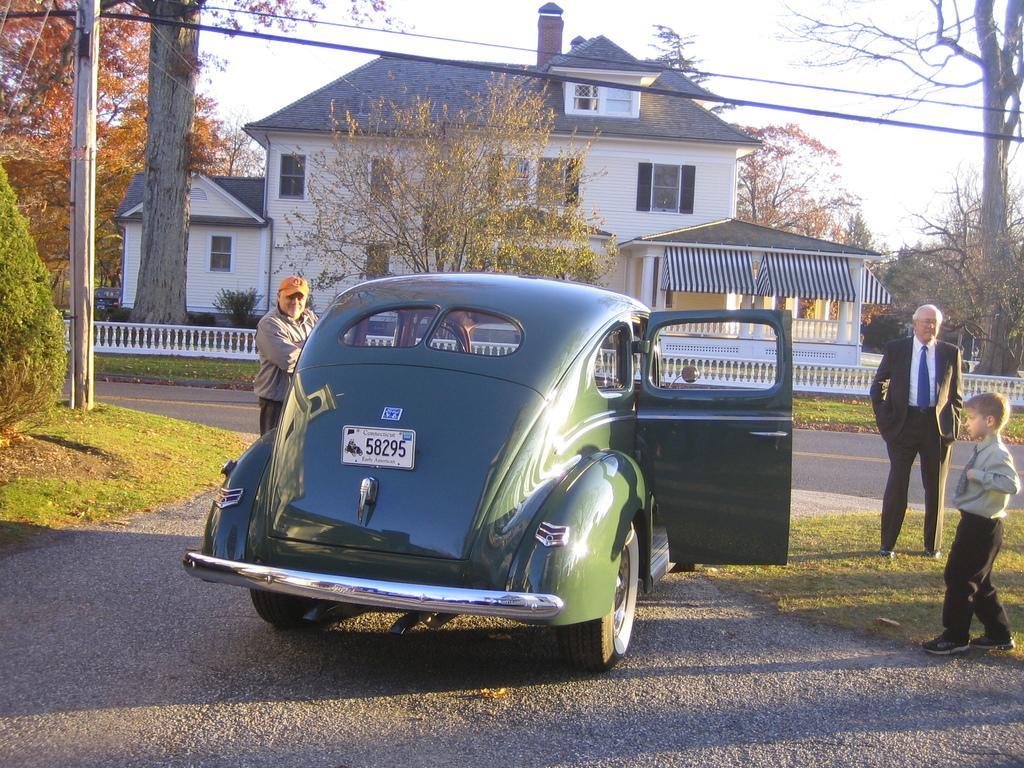Describe this image in one or two sentences. In this image there is a car on the road in the bottom of this image. There are some persons standing on the right side of this image and one person is standing on the left side to this car. There are some trees on the left side of this image and right side of this image as well. One tree is in the middle of this image and there is a building in the background. There is a sky on the top of this image. 